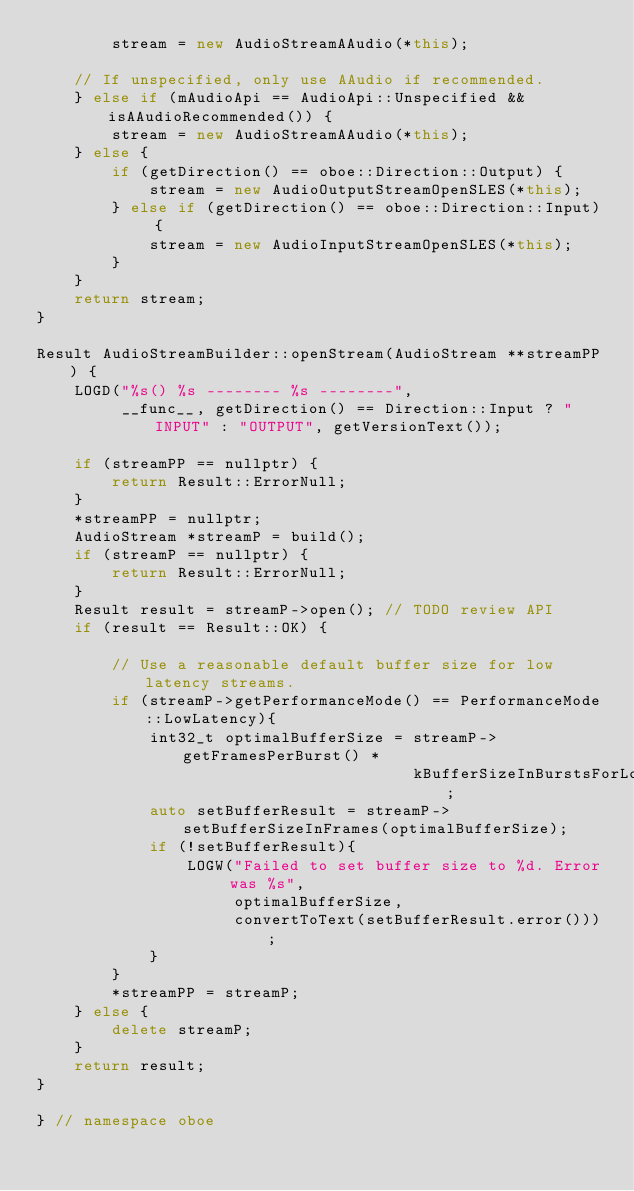<code> <loc_0><loc_0><loc_500><loc_500><_C++_>        stream = new AudioStreamAAudio(*this);

    // If unspecified, only use AAudio if recommended.
    } else if (mAudioApi == AudioApi::Unspecified && isAAudioRecommended()) {
        stream = new AudioStreamAAudio(*this);
    } else {
        if (getDirection() == oboe::Direction::Output) {
            stream = new AudioOutputStreamOpenSLES(*this);
        } else if (getDirection() == oboe::Direction::Input) {
            stream = new AudioInputStreamOpenSLES(*this);
        }
    }
    return stream;
}

Result AudioStreamBuilder::openStream(AudioStream **streamPP) {
    LOGD("%s() %s -------- %s --------",
         __func__, getDirection() == Direction::Input ? "INPUT" : "OUTPUT", getVersionText());

    if (streamPP == nullptr) {
        return Result::ErrorNull;
    }
    *streamPP = nullptr;
    AudioStream *streamP = build();
    if (streamP == nullptr) {
        return Result::ErrorNull;
    }
    Result result = streamP->open(); // TODO review API
    if (result == Result::OK) {

        // Use a reasonable default buffer size for low latency streams.
        if (streamP->getPerformanceMode() == PerformanceMode::LowLatency){
            int32_t optimalBufferSize = streamP->getFramesPerBurst() *
                                        kBufferSizeInBurstsForLowLatencyStreams;
            auto setBufferResult = streamP->setBufferSizeInFrames(optimalBufferSize);
            if (!setBufferResult){
                LOGW("Failed to set buffer size to %d. Error was %s",
                     optimalBufferSize,
                     convertToText(setBufferResult.error()));
            }
        }
        *streamPP = streamP;
    } else {
        delete streamP;
    }
    return result;
}

} // namespace oboe</code> 